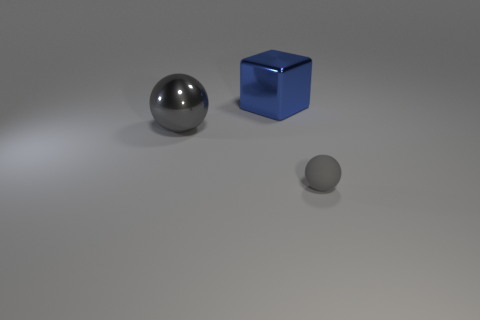Add 1 small rubber objects. How many objects exist? 4 Subtract all blocks. How many objects are left? 2 Subtract 0 brown balls. How many objects are left? 3 Subtract all tiny cyan things. Subtract all blue metal objects. How many objects are left? 2 Add 2 spheres. How many spheres are left? 4 Add 2 large cyan balls. How many large cyan balls exist? 2 